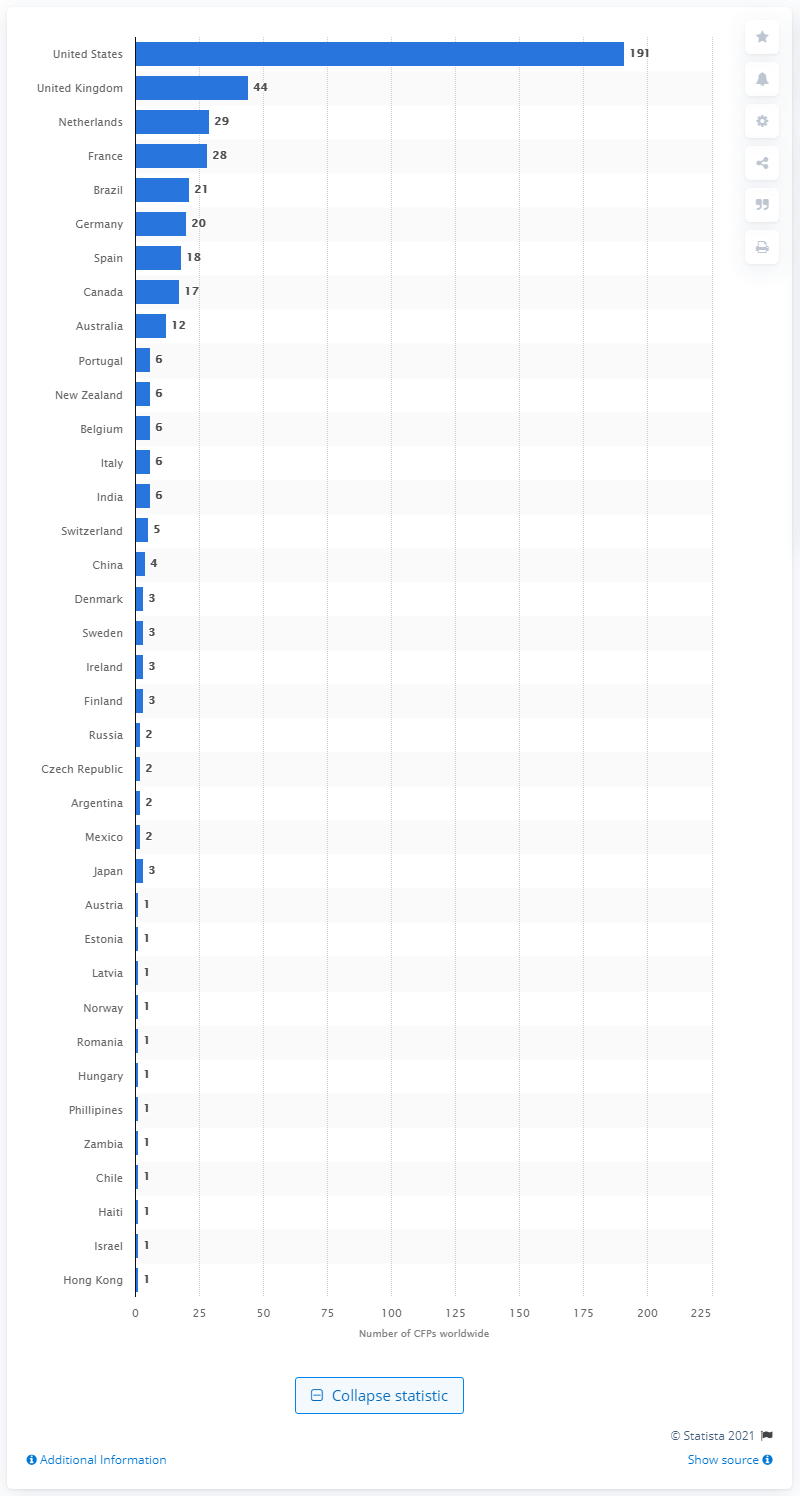Mention a couple of crucial points in this snapshot. In 2012, there were 191 crowdfunding platforms operating in the United States. 